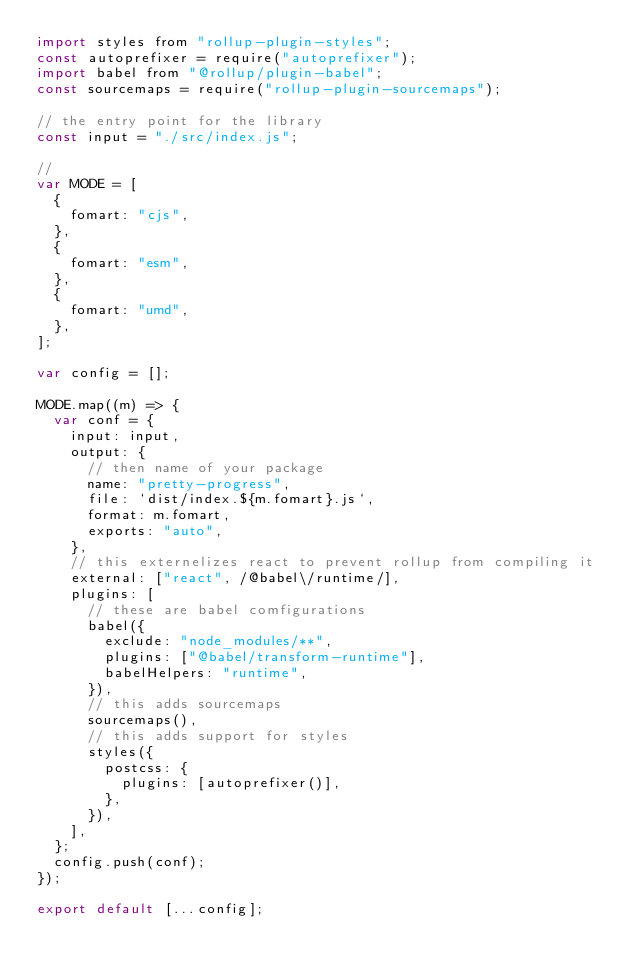<code> <loc_0><loc_0><loc_500><loc_500><_JavaScript_>import styles from "rollup-plugin-styles";
const autoprefixer = require("autoprefixer");
import babel from "@rollup/plugin-babel";
const sourcemaps = require("rollup-plugin-sourcemaps");

// the entry point for the library
const input = "./src/index.js";

//
var MODE = [
  {
    fomart: "cjs",
  },
  {
    fomart: "esm",
  },
  {
    fomart: "umd",
  },
];

var config = [];

MODE.map((m) => {
  var conf = {
    input: input,
    output: {
      // then name of your package
      name: "pretty-progress",
      file: `dist/index.${m.fomart}.js`,
      format: m.fomart,
      exports: "auto",
    },
    // this externelizes react to prevent rollup from compiling it
    external: ["react", /@babel\/runtime/],
    plugins: [
      // these are babel comfigurations
      babel({
        exclude: "node_modules/**",
        plugins: ["@babel/transform-runtime"],
        babelHelpers: "runtime",
      }),
      // this adds sourcemaps
      sourcemaps(),
      // this adds support for styles
      styles({
        postcss: {
          plugins: [autoprefixer()],
        },
      }),
    ],
  };
  config.push(conf);
});

export default [...config];
</code> 